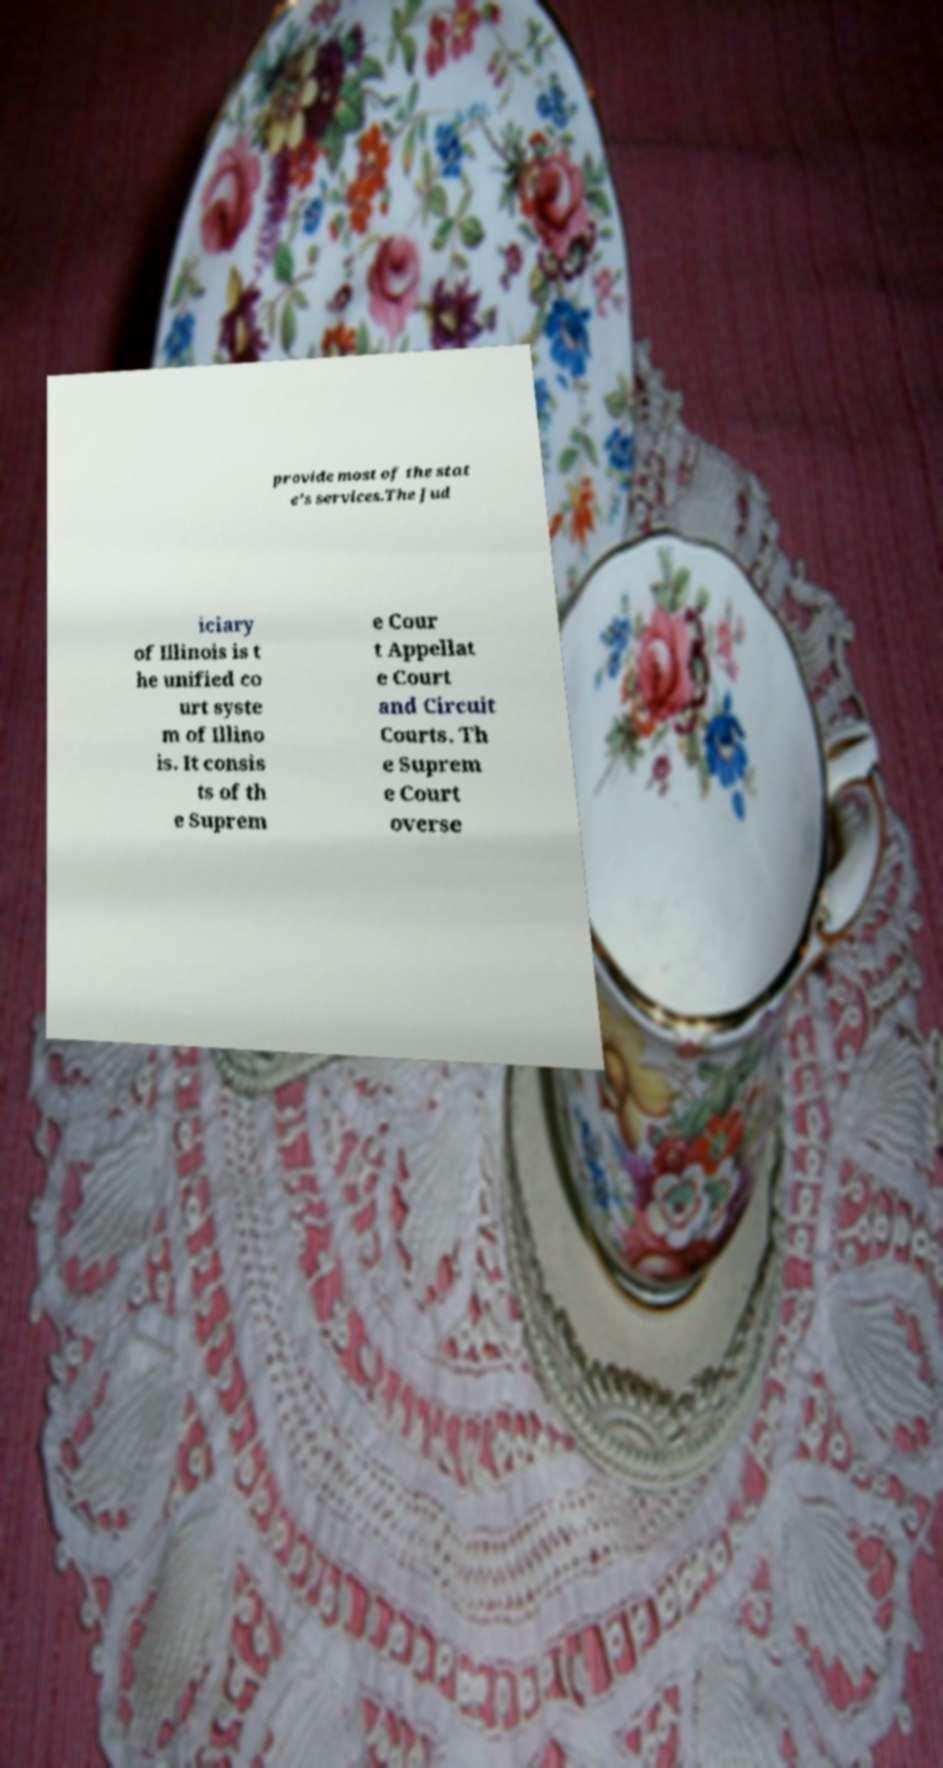Could you assist in decoding the text presented in this image and type it out clearly? provide most of the stat e's services.The Jud iciary of Illinois is t he unified co urt syste m of Illino is. It consis ts of th e Suprem e Cour t Appellat e Court and Circuit Courts. Th e Suprem e Court overse 